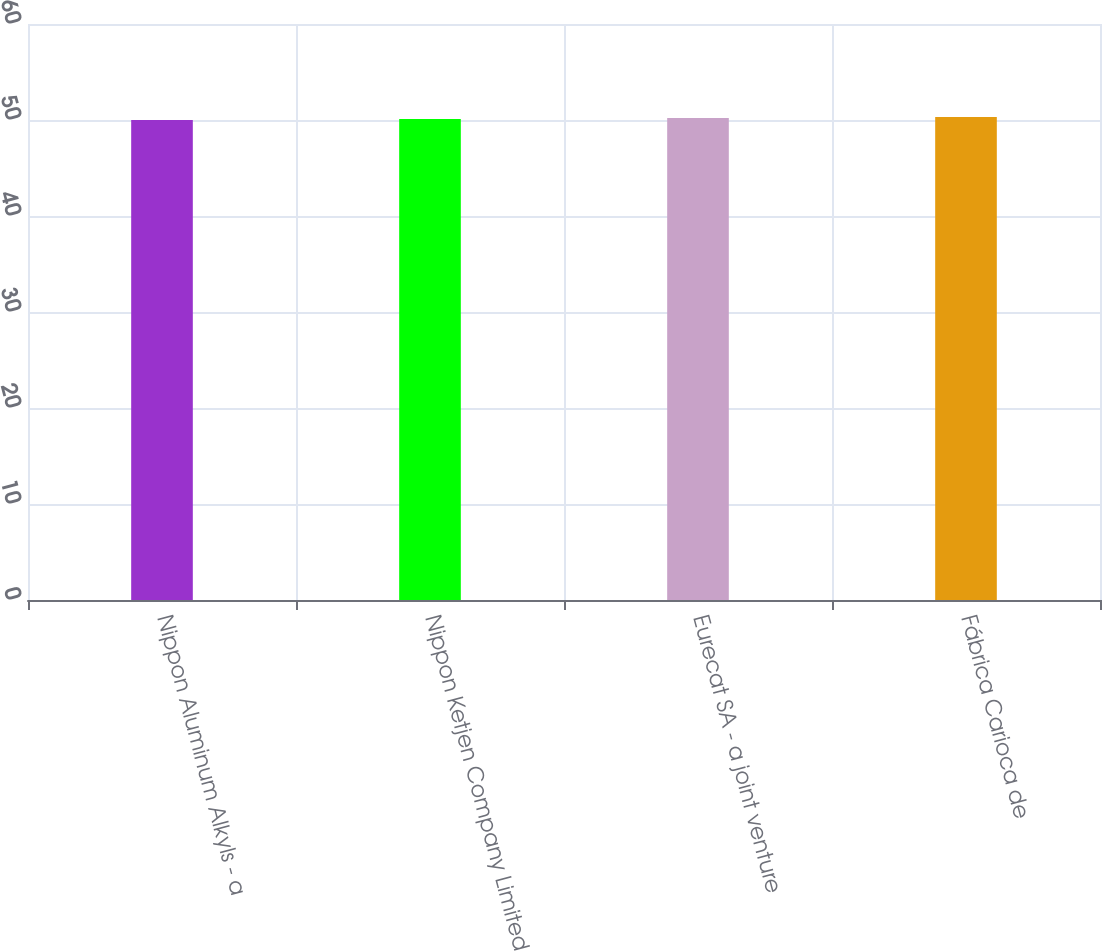<chart> <loc_0><loc_0><loc_500><loc_500><bar_chart><fcel>Nippon Aluminum Alkyls - a<fcel>Nippon Ketjen Company Limited<fcel>Eurecat SA - a joint venture<fcel>Fábrica Carioca de<nl><fcel>50<fcel>50.1<fcel>50.2<fcel>50.3<nl></chart> 